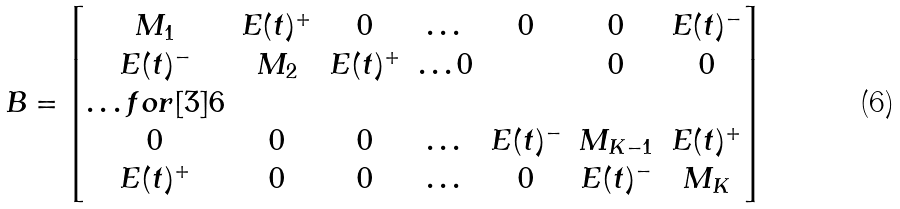<formula> <loc_0><loc_0><loc_500><loc_500>B = \begin{bmatrix} M _ { 1 } & E ( t ) ^ { + } & 0 & \dots & 0 & 0 & E ( t ) ^ { - } \\ E ( t ) ^ { - } & M _ { 2 } & E ( t ) ^ { + } & \dots 0 & & 0 & 0 \\ \hdots f o r [ 3 ] { 6 } \\ 0 & 0 & 0 & \dots & E ( t ) ^ { - } & M _ { K - 1 } & E ( t ) ^ { + } \\ E ( t ) ^ { + } & 0 & 0 & \dots & 0 & E ( t ) ^ { - } & M _ { K } \end{bmatrix}</formula> 